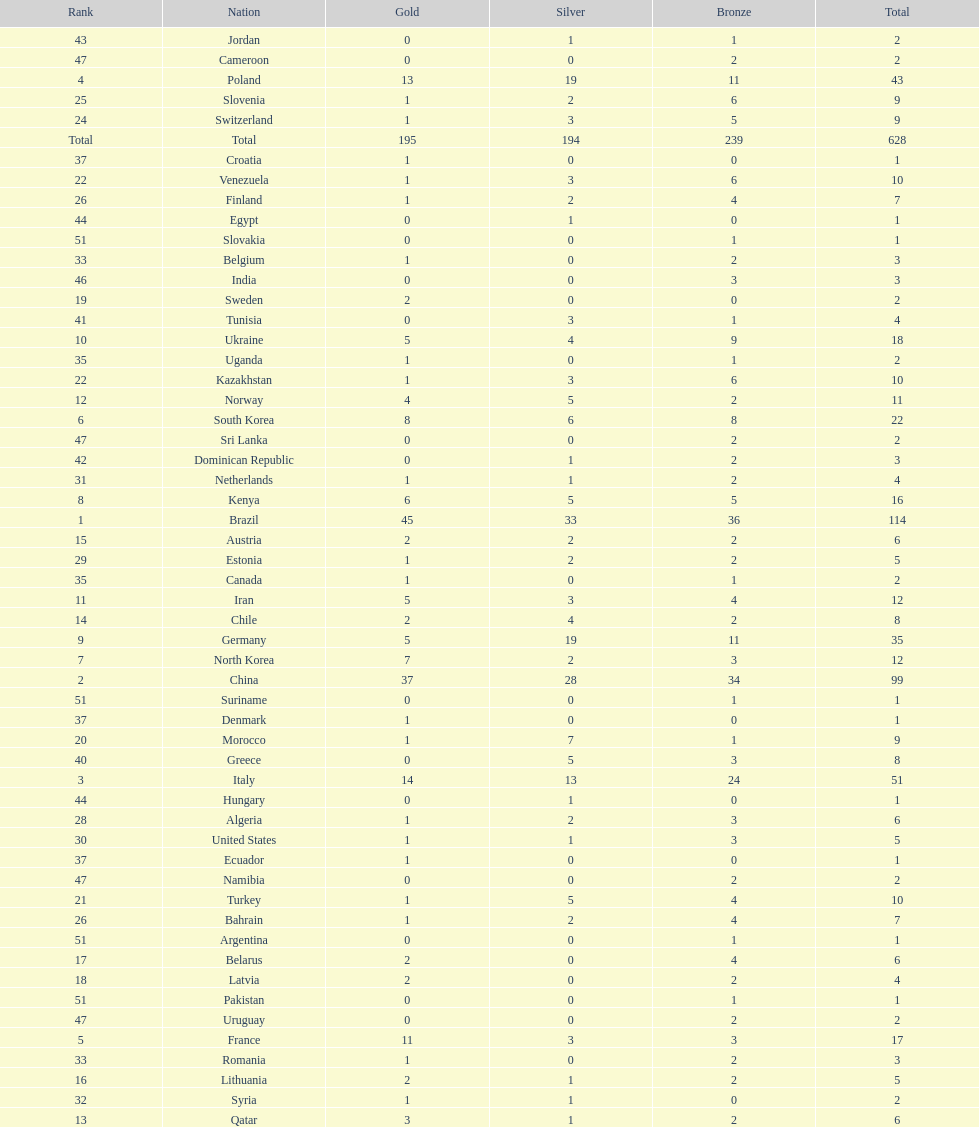Could you parse the entire table as a dict? {'header': ['Rank', 'Nation', 'Gold', 'Silver', 'Bronze', 'Total'], 'rows': [['43', 'Jordan', '0', '1', '1', '2'], ['47', 'Cameroon', '0', '0', '2', '2'], ['4', 'Poland', '13', '19', '11', '43'], ['25', 'Slovenia', '1', '2', '6', '9'], ['24', 'Switzerland', '1', '3', '5', '9'], ['Total', 'Total', '195', '194', '239', '628'], ['37', 'Croatia', '1', '0', '0', '1'], ['22', 'Venezuela', '1', '3', '6', '10'], ['26', 'Finland', '1', '2', '4', '7'], ['44', 'Egypt', '0', '1', '0', '1'], ['51', 'Slovakia', '0', '0', '1', '1'], ['33', 'Belgium', '1', '0', '2', '3'], ['46', 'India', '0', '0', '3', '3'], ['19', 'Sweden', '2', '0', '0', '2'], ['41', 'Tunisia', '0', '3', '1', '4'], ['10', 'Ukraine', '5', '4', '9', '18'], ['35', 'Uganda', '1', '0', '1', '2'], ['22', 'Kazakhstan', '1', '3', '6', '10'], ['12', 'Norway', '4', '5', '2', '11'], ['6', 'South Korea', '8', '6', '8', '22'], ['47', 'Sri Lanka', '0', '0', '2', '2'], ['42', 'Dominican Republic', '0', '1', '2', '3'], ['31', 'Netherlands', '1', '1', '2', '4'], ['8', 'Kenya', '6', '5', '5', '16'], ['1', 'Brazil', '45', '33', '36', '114'], ['15', 'Austria', '2', '2', '2', '6'], ['29', 'Estonia', '1', '2', '2', '5'], ['35', 'Canada', '1', '0', '1', '2'], ['11', 'Iran', '5', '3', '4', '12'], ['14', 'Chile', '2', '4', '2', '8'], ['9', 'Germany', '5', '19', '11', '35'], ['7', 'North Korea', '7', '2', '3', '12'], ['2', 'China', '37', '28', '34', '99'], ['51', 'Suriname', '0', '0', '1', '1'], ['37', 'Denmark', '1', '0', '0', '1'], ['20', 'Morocco', '1', '7', '1', '9'], ['40', 'Greece', '0', '5', '3', '8'], ['3', 'Italy', '14', '13', '24', '51'], ['44', 'Hungary', '0', '1', '0', '1'], ['28', 'Algeria', '1', '2', '3', '6'], ['30', 'United States', '1', '1', '3', '5'], ['37', 'Ecuador', '1', '0', '0', '1'], ['47', 'Namibia', '0', '0', '2', '2'], ['21', 'Turkey', '1', '5', '4', '10'], ['26', 'Bahrain', '1', '2', '4', '7'], ['51', 'Argentina', '0', '0', '1', '1'], ['17', 'Belarus', '2', '0', '4', '6'], ['18', 'Latvia', '2', '0', '2', '4'], ['51', 'Pakistan', '0', '0', '1', '1'], ['47', 'Uruguay', '0', '0', '2', '2'], ['5', 'France', '11', '3', '3', '17'], ['33', 'Romania', '1', '0', '2', '3'], ['16', 'Lithuania', '2', '1', '2', '5'], ['32', 'Syria', '1', '1', '0', '2'], ['13', 'Qatar', '3', '1', '2', '6']]} Which type of medal does belarus not have? Silver. 